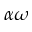<formula> <loc_0><loc_0><loc_500><loc_500>\alpha \omega</formula> 